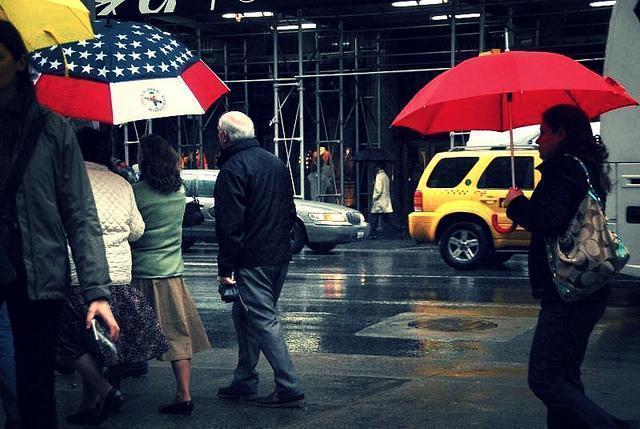One of the umbrellas is inspired by which country's flag?
Indicate the correct response and explain using: 'Answer: answer
Rationale: rationale.'
Options: Morocco, germany, usa, denmark. Answer: usa.
Rationale: It has red,white,blue and stars. 